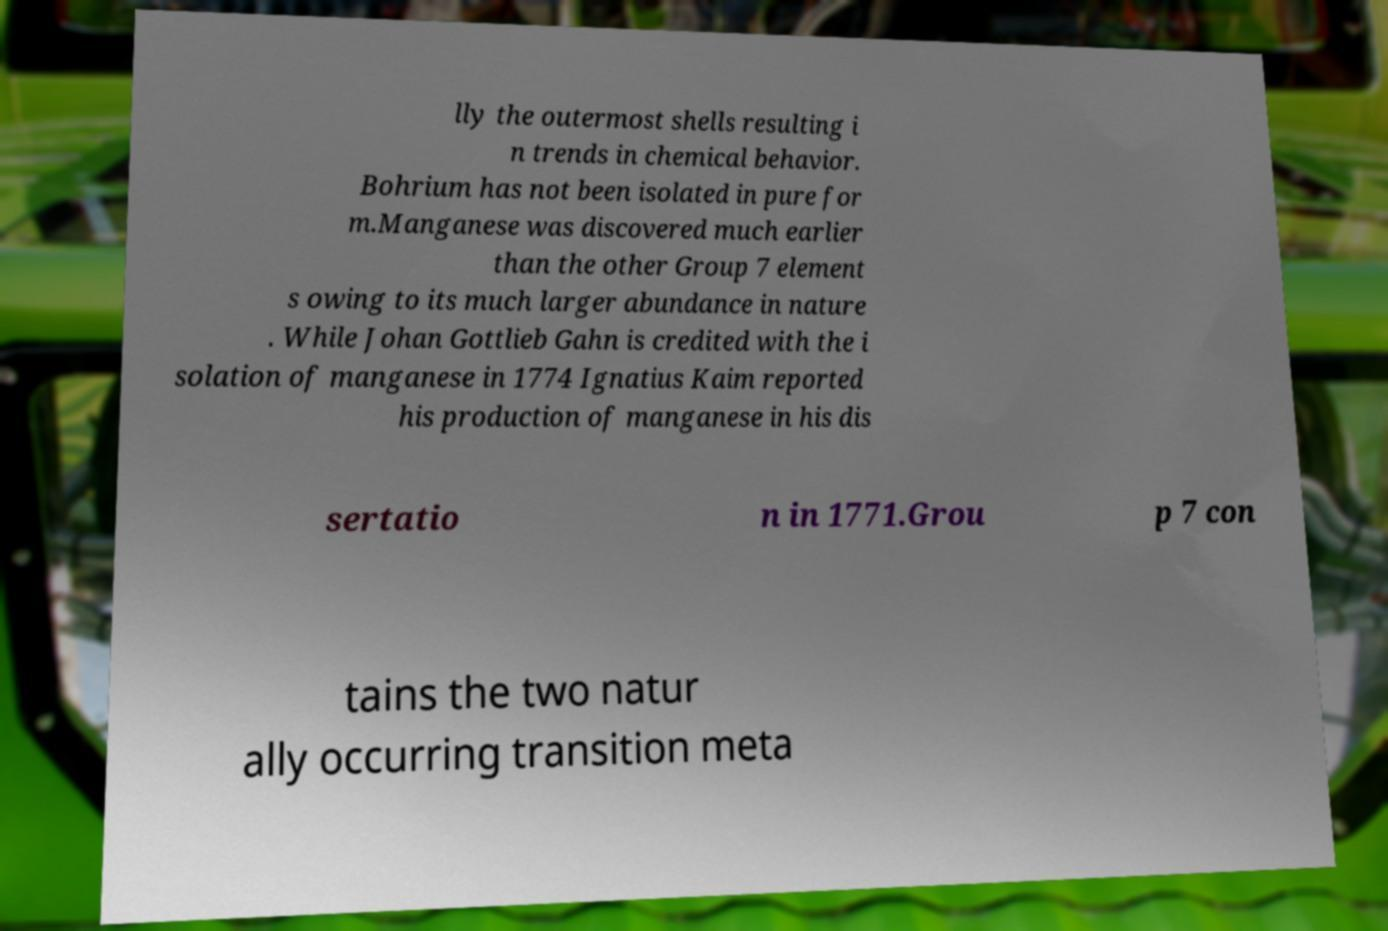What messages or text are displayed in this image? I need them in a readable, typed format. lly the outermost shells resulting i n trends in chemical behavior. Bohrium has not been isolated in pure for m.Manganese was discovered much earlier than the other Group 7 element s owing to its much larger abundance in nature . While Johan Gottlieb Gahn is credited with the i solation of manganese in 1774 Ignatius Kaim reported his production of manganese in his dis sertatio n in 1771.Grou p 7 con tains the two natur ally occurring transition meta 